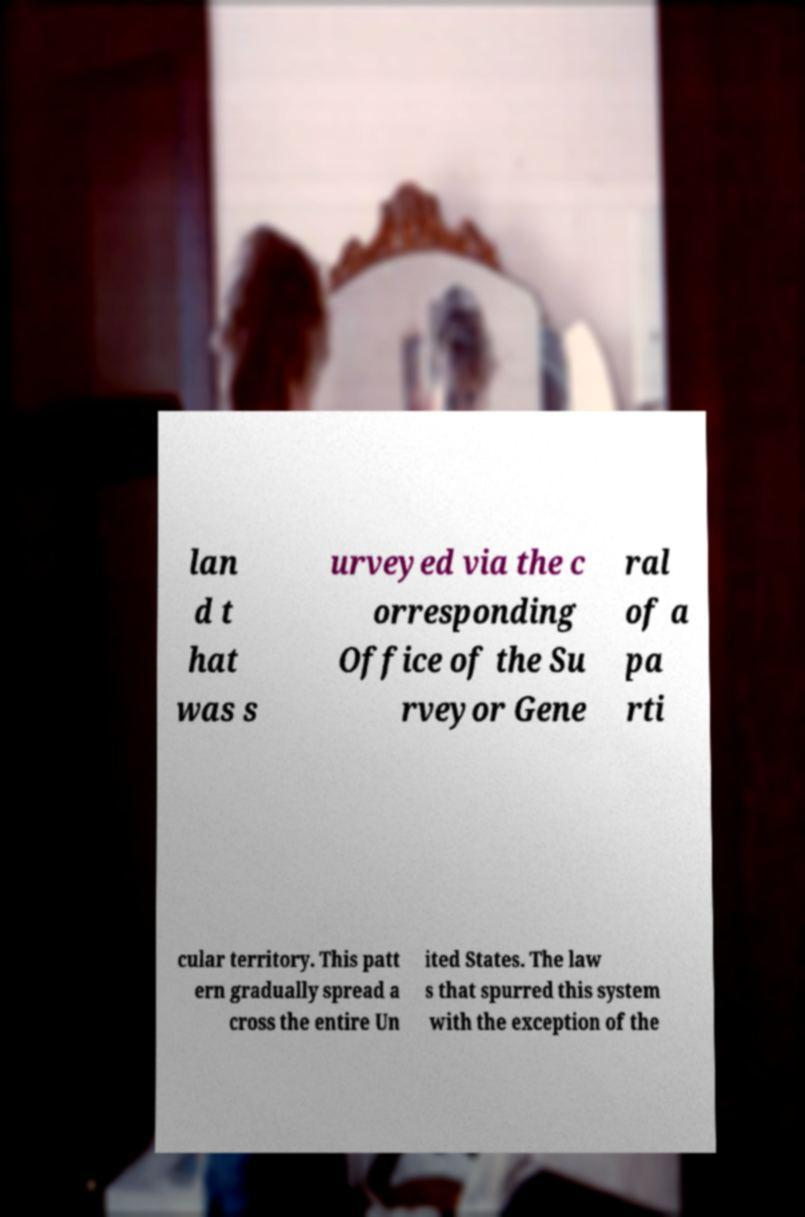What messages or text are displayed in this image? I need them in a readable, typed format. lan d t hat was s urveyed via the c orresponding Office of the Su rveyor Gene ral of a pa rti cular territory. This patt ern gradually spread a cross the entire Un ited States. The law s that spurred this system with the exception of the 